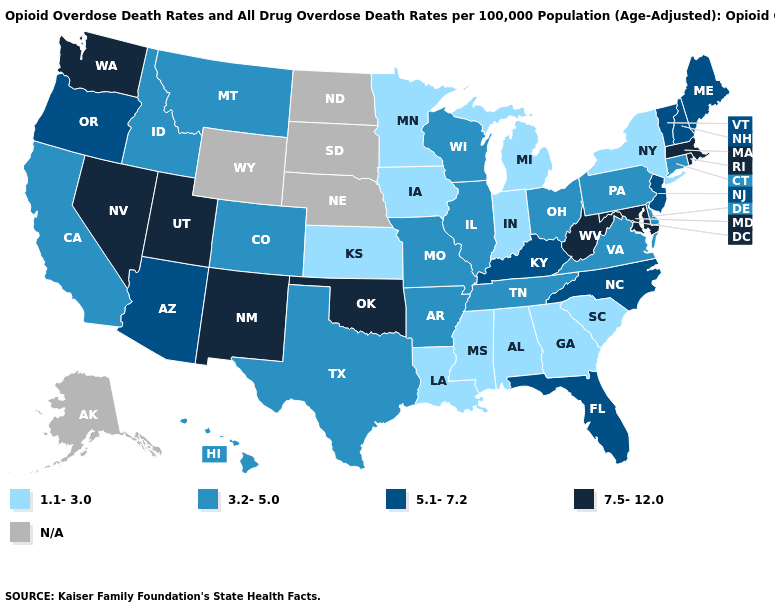Name the states that have a value in the range N/A?
Short answer required. Alaska, Nebraska, North Dakota, South Dakota, Wyoming. What is the lowest value in the USA?
Concise answer only. 1.1-3.0. What is the highest value in states that border Alabama?
Write a very short answer. 5.1-7.2. What is the lowest value in the USA?
Give a very brief answer. 1.1-3.0. Which states have the highest value in the USA?
Quick response, please. Maryland, Massachusetts, Nevada, New Mexico, Oklahoma, Rhode Island, Utah, Washington, West Virginia. What is the value of Ohio?
Keep it brief. 3.2-5.0. Name the states that have a value in the range 3.2-5.0?
Write a very short answer. Arkansas, California, Colorado, Connecticut, Delaware, Hawaii, Idaho, Illinois, Missouri, Montana, Ohio, Pennsylvania, Tennessee, Texas, Virginia, Wisconsin. What is the highest value in the South ?
Give a very brief answer. 7.5-12.0. Name the states that have a value in the range N/A?
Give a very brief answer. Alaska, Nebraska, North Dakota, South Dakota, Wyoming. Does Minnesota have the lowest value in the USA?
Short answer required. Yes. Among the states that border Delaware , which have the highest value?
Be succinct. Maryland. Does Minnesota have the highest value in the MidWest?
Concise answer only. No. What is the value of North Dakota?
Short answer required. N/A. Among the states that border Florida , which have the highest value?
Quick response, please. Alabama, Georgia. 